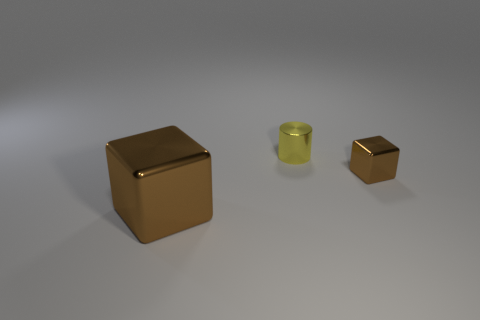Add 2 big red spheres. How many objects exist? 5 Subtract all blocks. How many objects are left? 1 Subtract all big brown cubes. Subtract all tiny red metallic cylinders. How many objects are left? 2 Add 2 big objects. How many big objects are left? 3 Add 2 cubes. How many cubes exist? 4 Subtract 0 green cylinders. How many objects are left? 3 